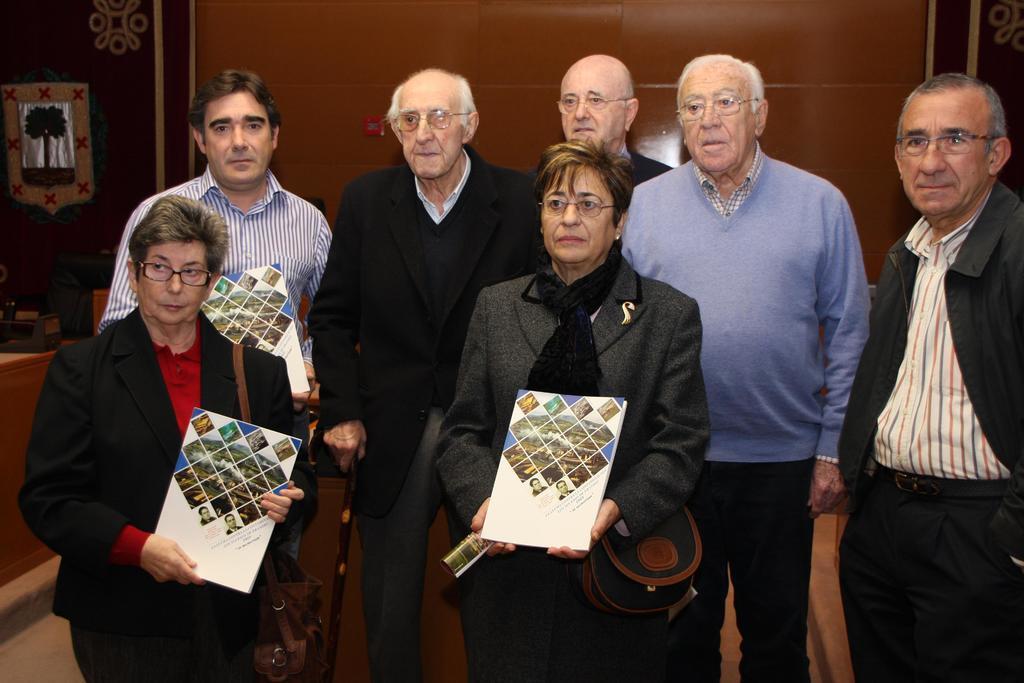In one or two sentences, can you explain what this image depicts? In this image there are two women standing, there are five men standing, the women are wearing a bag, the persons are holding an object, there is a wooden object towards the left of the image, at the background of the image there is a wall, there is an object on the wall, there is a painting on the wall. 